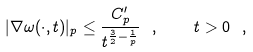<formula> <loc_0><loc_0><loc_500><loc_500>| \nabla \omega ( \cdot , t ) | _ { p } \leq \frac { C _ { p } ^ { \prime } } { t ^ { \frac { 3 } { 2 } - \frac { 1 } { p } } } \ , \quad t > 0 \ ,</formula> 